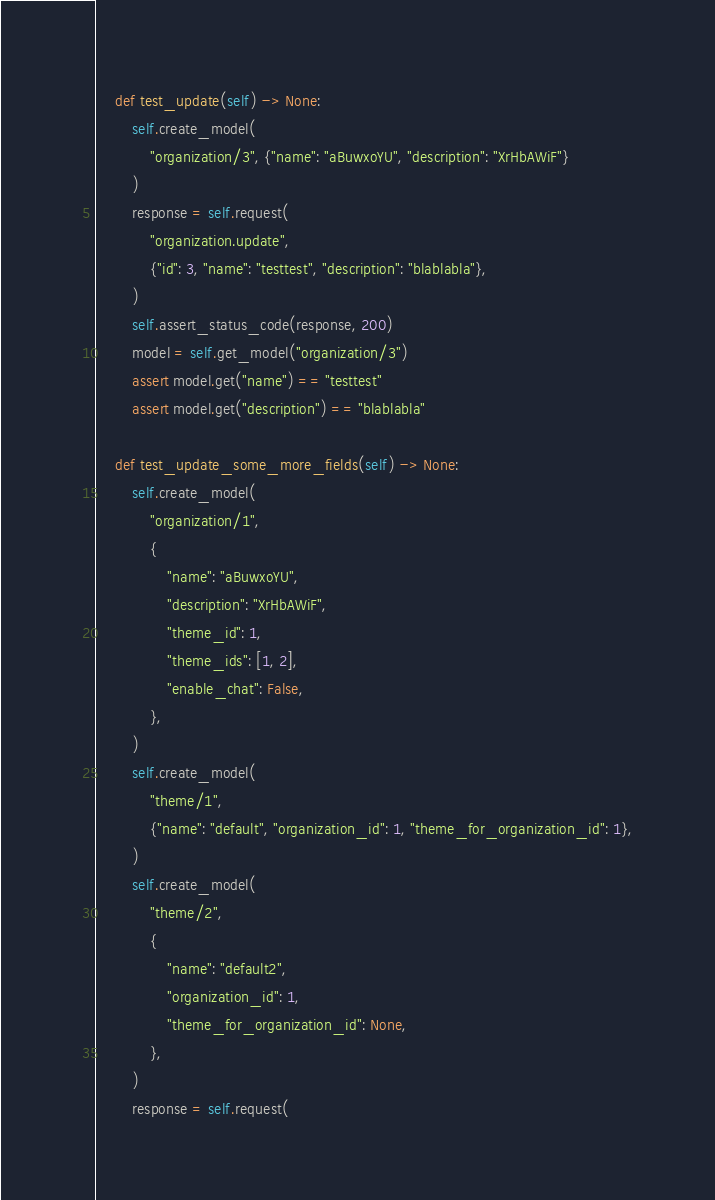Convert code to text. <code><loc_0><loc_0><loc_500><loc_500><_Python_>    def test_update(self) -> None:
        self.create_model(
            "organization/3", {"name": "aBuwxoYU", "description": "XrHbAWiF"}
        )
        response = self.request(
            "organization.update",
            {"id": 3, "name": "testtest", "description": "blablabla"},
        )
        self.assert_status_code(response, 200)
        model = self.get_model("organization/3")
        assert model.get("name") == "testtest"
        assert model.get("description") == "blablabla"

    def test_update_some_more_fields(self) -> None:
        self.create_model(
            "organization/1",
            {
                "name": "aBuwxoYU",
                "description": "XrHbAWiF",
                "theme_id": 1,
                "theme_ids": [1, 2],
                "enable_chat": False,
            },
        )
        self.create_model(
            "theme/1",
            {"name": "default", "organization_id": 1, "theme_for_organization_id": 1},
        )
        self.create_model(
            "theme/2",
            {
                "name": "default2",
                "organization_id": 1,
                "theme_for_organization_id": None,
            },
        )
        response = self.request(</code> 